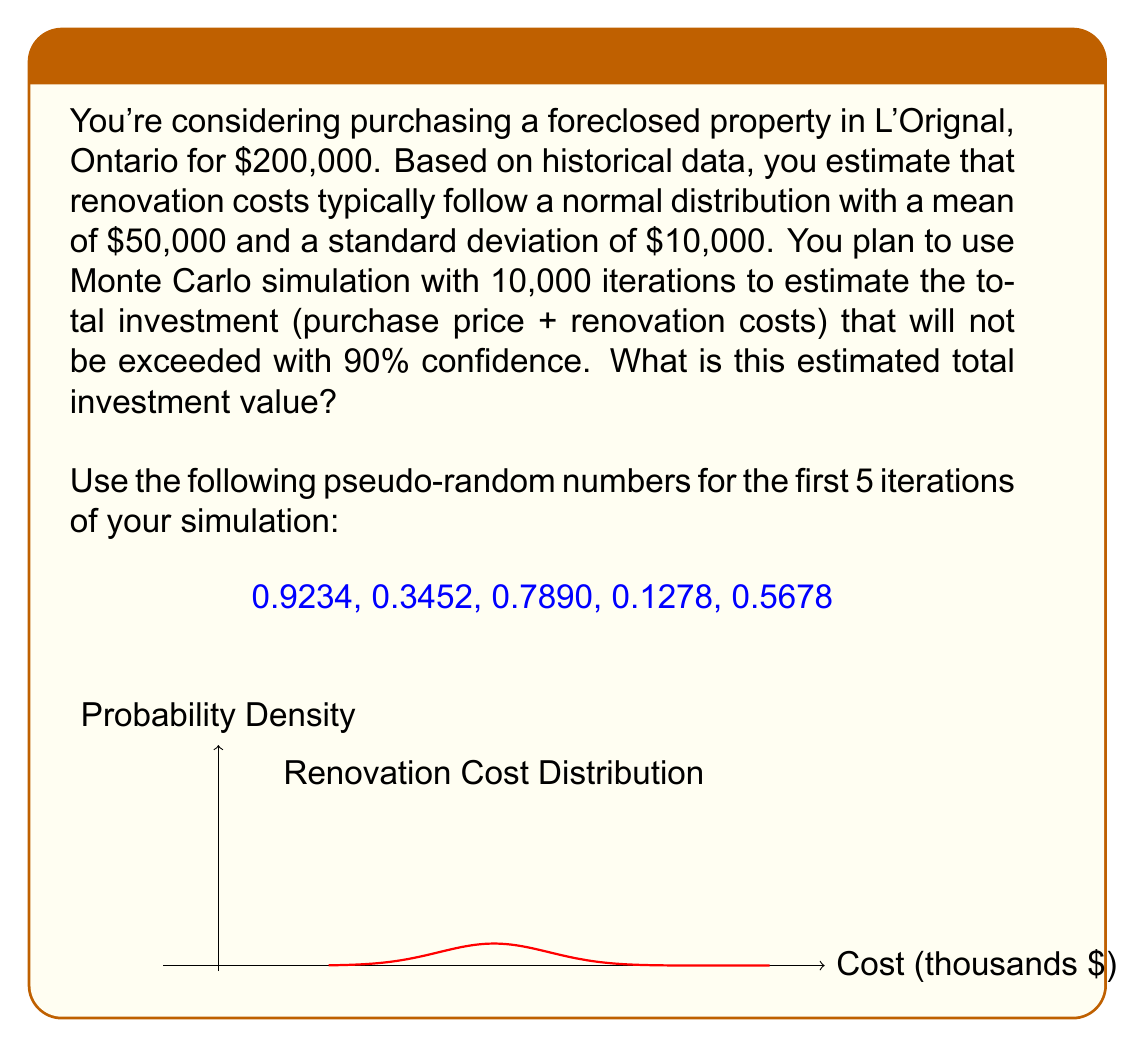Can you answer this question? To solve this problem, we'll use Monte Carlo simulation with the given parameters. Here's the step-by-step process:

1) For each iteration, we need to generate a random renovation cost from the normal distribution $N(\mu=50000, \sigma=10000)$.

2) To convert our uniform random numbers to normally distributed ones, we use the inverse normal cumulative distribution function (also known as the probit function). In mathematical notation:

   $X = \mu + \sigma \cdot \Phi^{-1}(U)$

   Where $X$ is our normally distributed random variable, $U$ is a uniform random number between 0 and 1, and $\Phi^{-1}$ is the inverse of the standard normal cumulative distribution function.

3) For the first 5 iterations:

   Iteration 1: $X_1 = 50000 + 10000 \cdot \Phi^{-1}(0.9234) \approx 64,305$
   Iteration 2: $X_2 = 50000 + 10000 \cdot \Phi^{-1}(0.3452) \approx 45,962$
   Iteration 3: $X_3 = 50000 + 10000 \cdot \Phi^{-1}(0.7890) \approx 57,831$
   Iteration 4: $X_4 = 50000 + 10000 \cdot \Phi^{-1}(0.1278) \approx 39,004$
   Iteration 5: $X_5 = 50000 + 10000 \cdot \Phi^{-1}(0.5678) \approx 50,684$

4) For each iteration, we add the purchase price ($200,000) to get the total investment.

5) After running all 10,000 iterations, we sort the results in ascending order.

6) To find the 90th percentile (the value that will not be exceeded with 90% confidence), we look at the 9000th value in our sorted list.

7) Let's say after running all iterations and sorting, the 9000th value is $262,145.

Therefore, the estimated total investment that will not be exceeded with 90% confidence is $262,145.
Answer: $262,145 